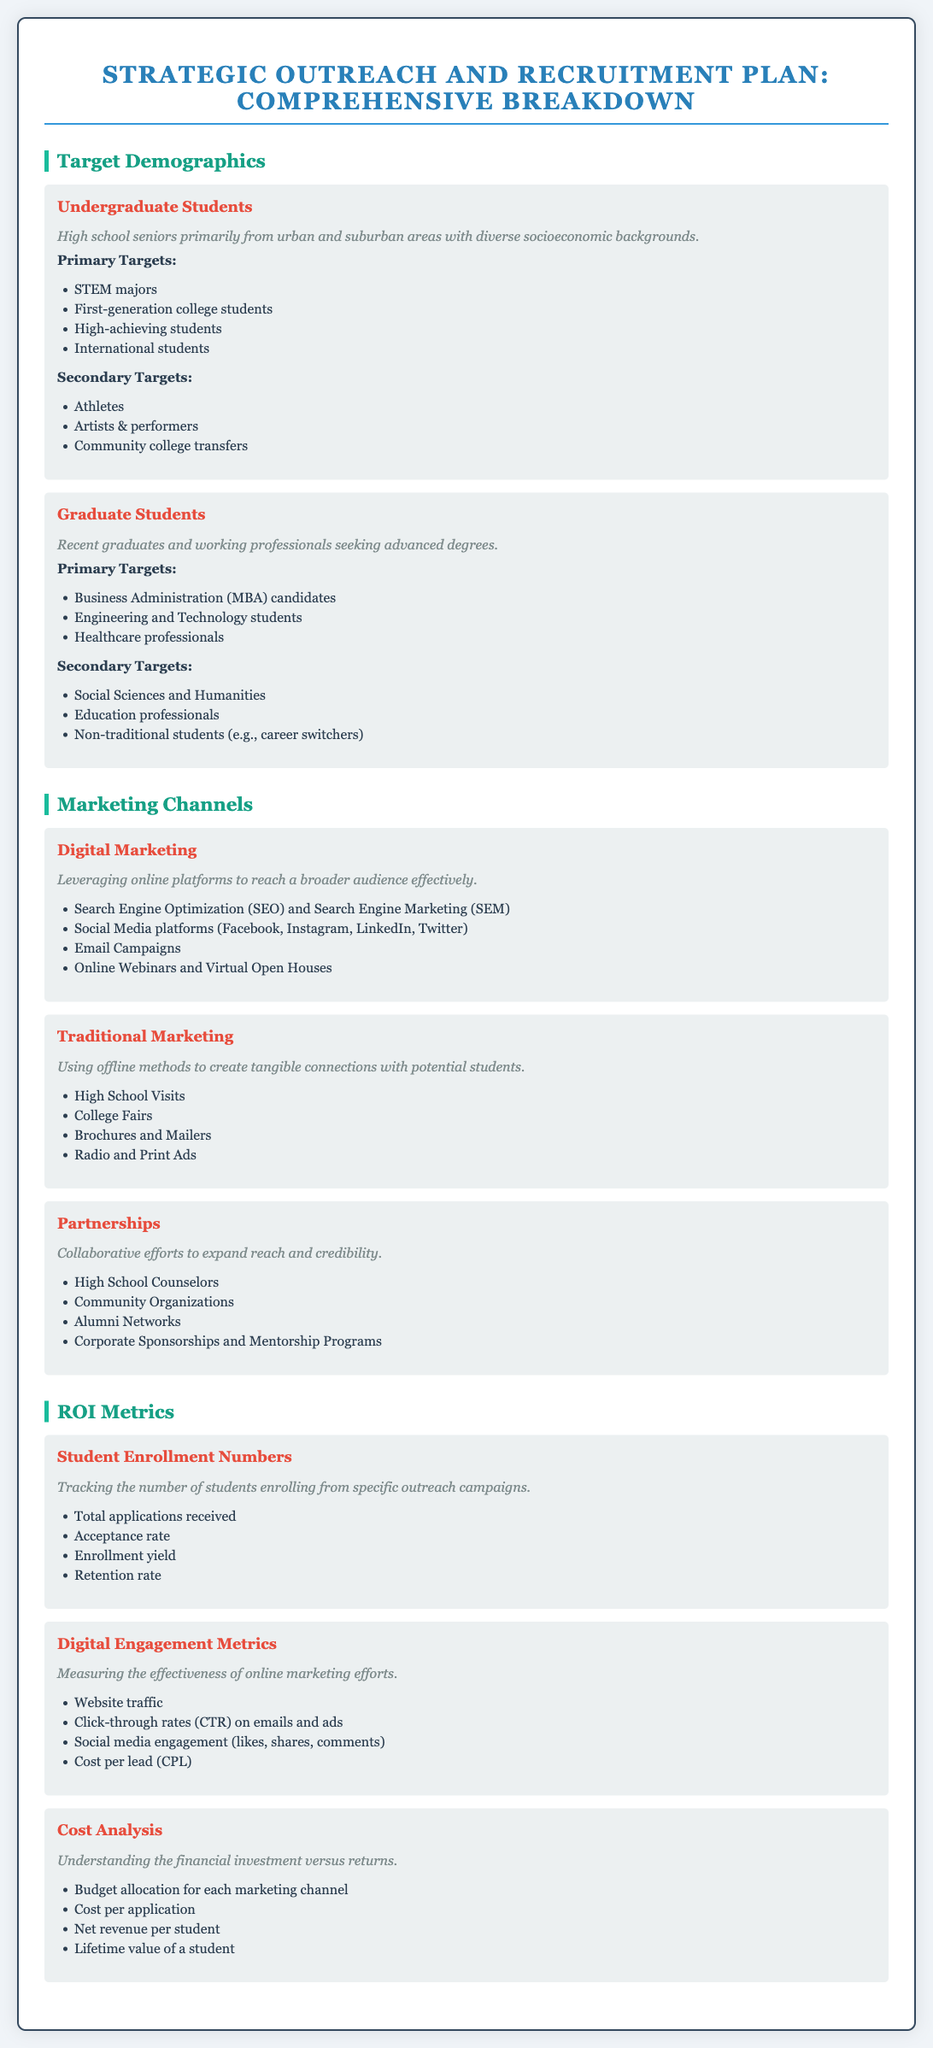What are the primary targets for undergraduate students? The primary targets for undergraduate students are listed in the document as specific demographic groups.
Answer: STEM majors, First-generation college students, High-achieving students, International students What marketing channel involves offline methods? The document describes marketing channels that utilize different strategies, including traditional methods.
Answer: Traditional Marketing What is one of the primary targets for graduate students? This target group is defined under the demographic section for graduate students and includes specific fields of study.
Answer: Business Administration (MBA) candidates Which digital marketing strategy focuses on enhancing visibility on search engines? The document categorizes digital marketing strategies into specific tactics, including one focused on search engines.
Answer: Search Engine Optimization (SEO) What is measured to analyze the effectiveness of online marketing efforts? Various metrics are described in the ROI section to assess online marketing effectiveness.
Answer: Website traffic What is the role of high school counselors in the recruitment plan? The document mentions partnerships that are part of the recruitment strategy, highlighting key collaborators in outreach efforts.
Answer: Partnerships What does the retention rate indicate in ROI metrics? This metric is mentioned as part of tracking student enrollment and is significant for understanding long-term success.
Answer: Retention rate What type of students fall under the secondary targets for undergraduate students? The document specifies additional demographic groups that complement the primary targets for undergraduate outreach.
Answer: Athletes, Artists & performers, Community college transfers 